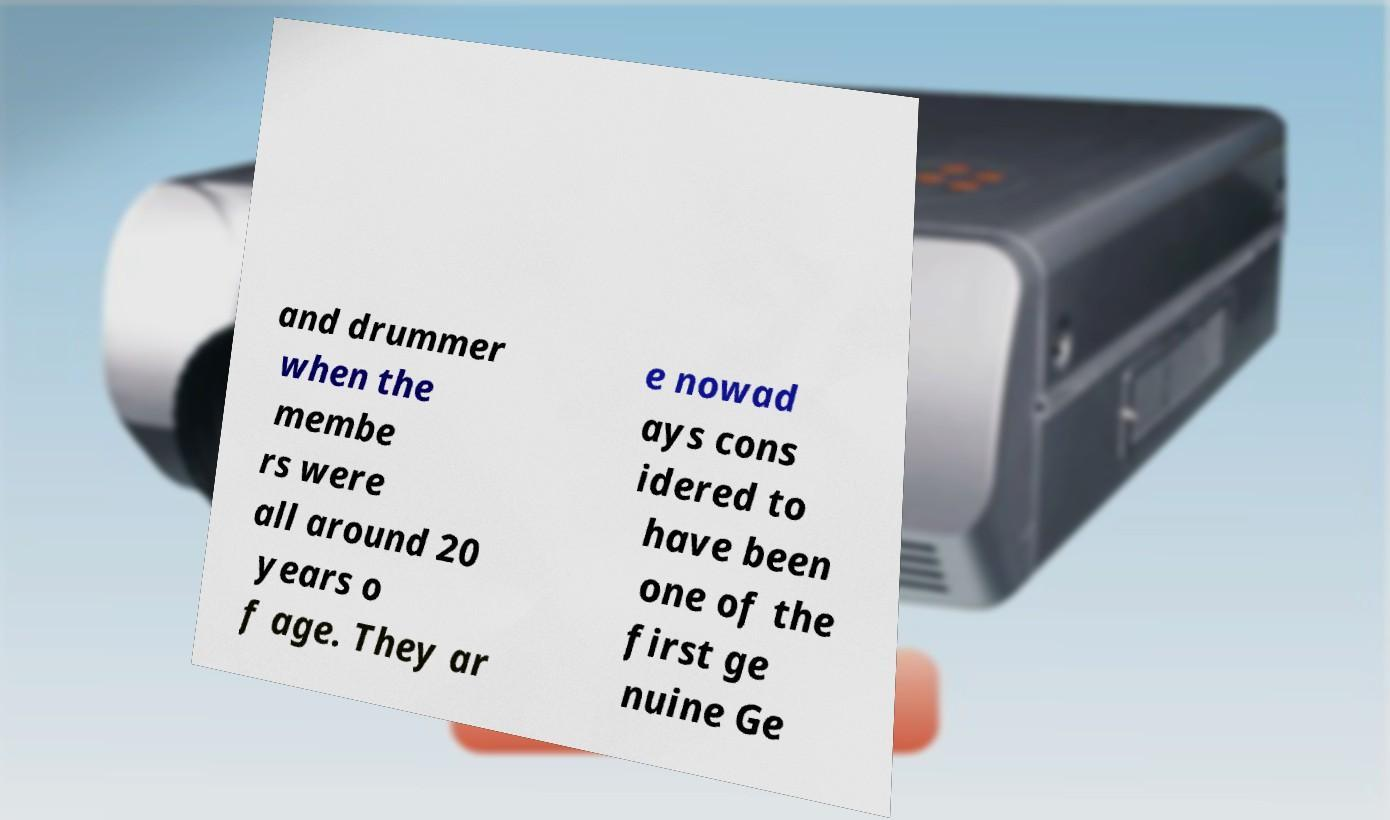Could you assist in decoding the text presented in this image and type it out clearly? and drummer when the membe rs were all around 20 years o f age. They ar e nowad ays cons idered to have been one of the first ge nuine Ge 